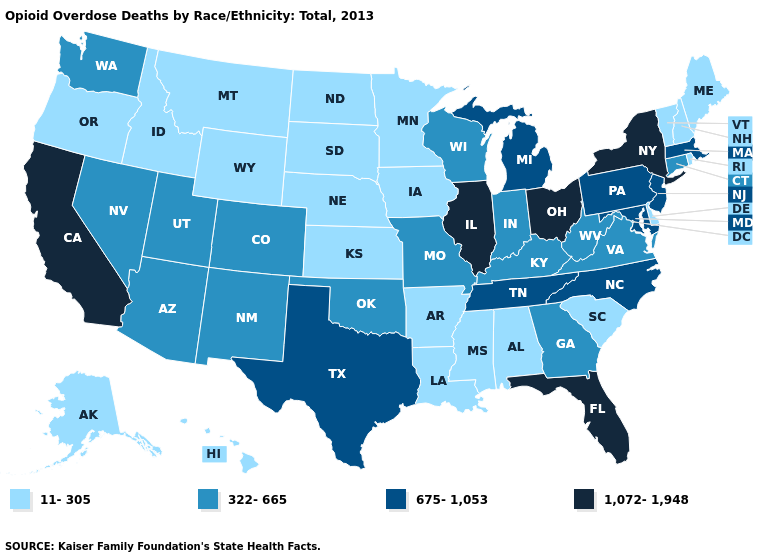Which states hav the highest value in the Northeast?
Quick response, please. New York. What is the lowest value in states that border Kentucky?
Quick response, please. 322-665. Does Ohio have the highest value in the MidWest?
Give a very brief answer. Yes. What is the lowest value in the USA?
Give a very brief answer. 11-305. Name the states that have a value in the range 675-1,053?
Write a very short answer. Maryland, Massachusetts, Michigan, New Jersey, North Carolina, Pennsylvania, Tennessee, Texas. What is the value of Texas?
Quick response, please. 675-1,053. Name the states that have a value in the range 322-665?
Short answer required. Arizona, Colorado, Connecticut, Georgia, Indiana, Kentucky, Missouri, Nevada, New Mexico, Oklahoma, Utah, Virginia, Washington, West Virginia, Wisconsin. What is the value of Indiana?
Answer briefly. 322-665. What is the value of Hawaii?
Short answer required. 11-305. Which states hav the highest value in the MidWest?
Be succinct. Illinois, Ohio. Does Florida have the highest value in the USA?
Give a very brief answer. Yes. Among the states that border Arizona , does New Mexico have the highest value?
Be succinct. No. Does South Carolina have the lowest value in the USA?
Concise answer only. Yes. Does Idaho have a lower value than Nebraska?
Concise answer only. No. What is the value of South Dakota?
Give a very brief answer. 11-305. 